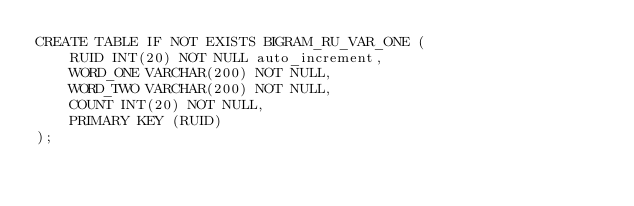Convert code to text. <code><loc_0><loc_0><loc_500><loc_500><_SQL_>CREATE TABLE IF NOT EXISTS BIGRAM_RU_VAR_ONE (
	RUID INT(20) NOT NULL auto_increment,
    WORD_ONE VARCHAR(200) NOT NULL,
    WORD_TWO VARCHAR(200) NOT NULL,
    COUNT INT(20) NOT NULL,
    PRIMARY KEY (RUID)
);

</code> 